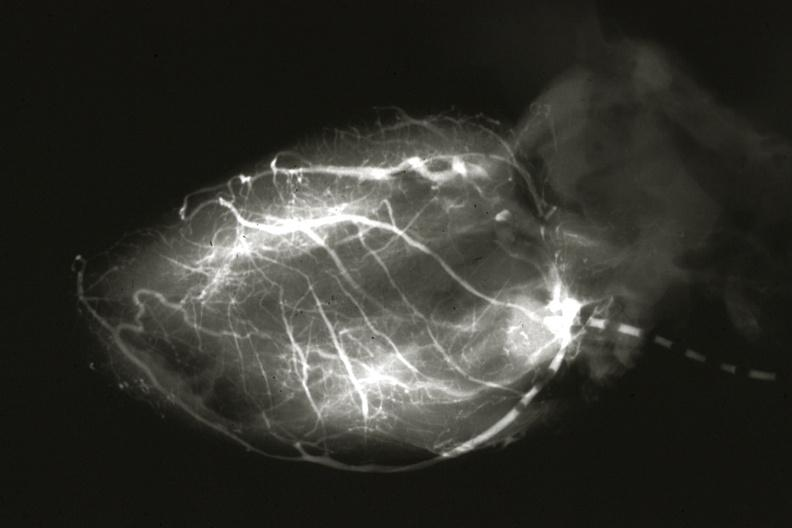what is present?
Answer the question using a single word or phrase. Cardiovascular 